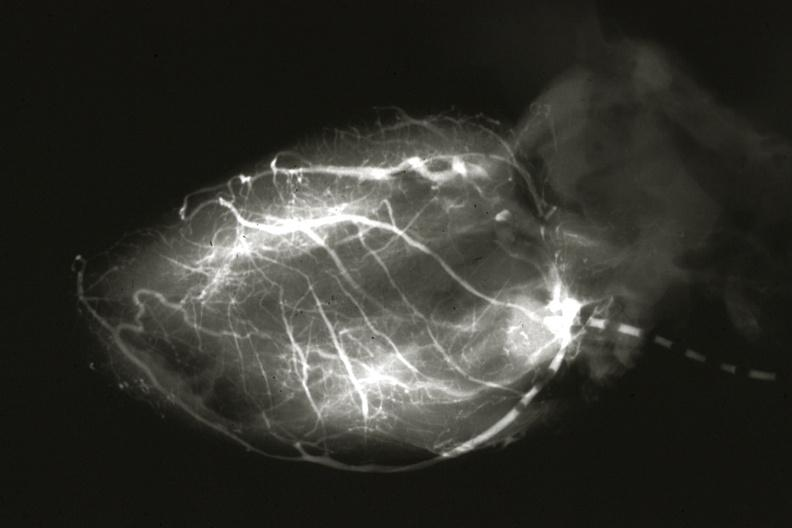what is present?
Answer the question using a single word or phrase. Cardiovascular 